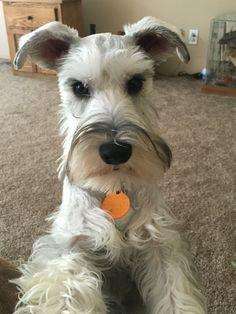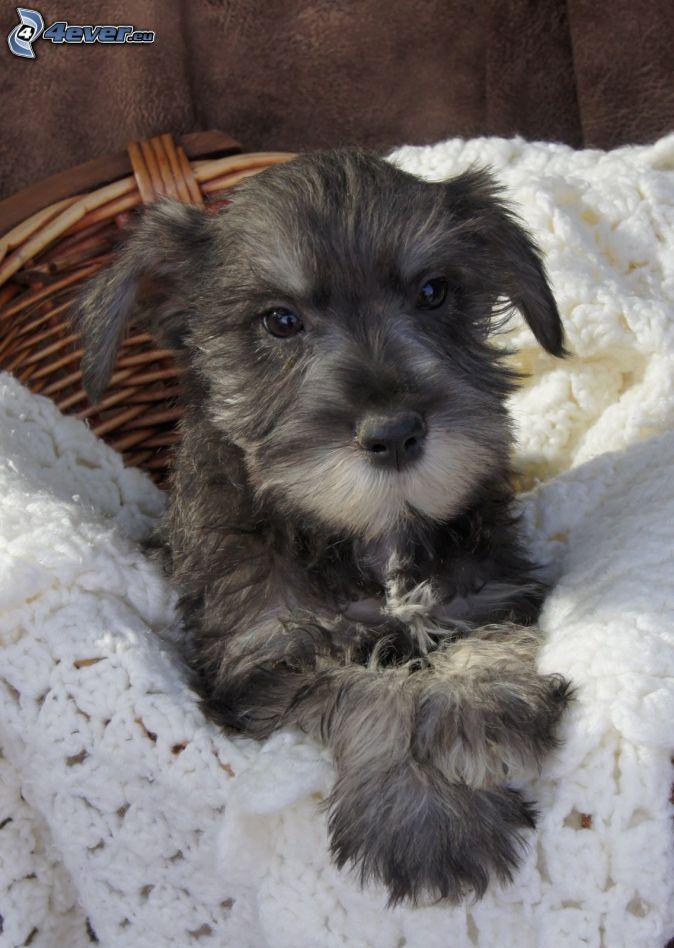The first image is the image on the left, the second image is the image on the right. Assess this claim about the two images: "The left image contains at least two dogs.". Correct or not? Answer yes or no. No. The first image is the image on the left, the second image is the image on the right. Considering the images on both sides, is "Each image contains one forward-facing schnauzer, and one image features a dog with a tag charm dangling under its chin." valid? Answer yes or no. Yes. 